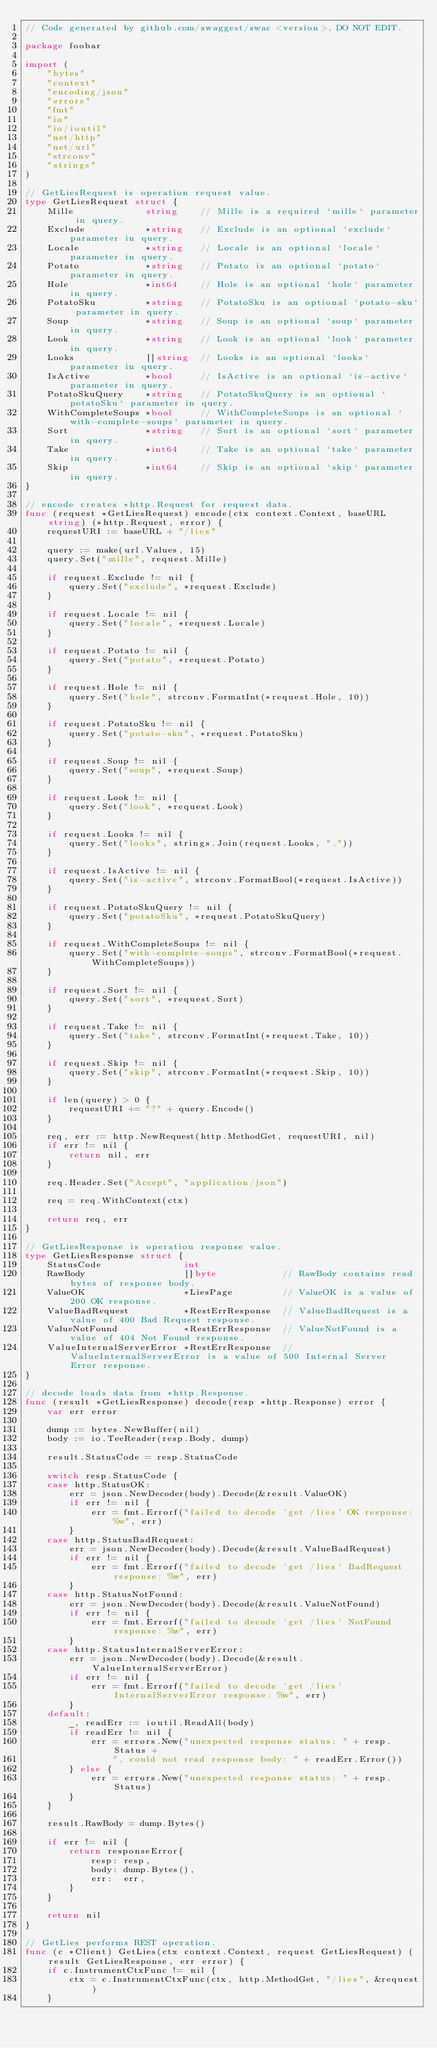<code> <loc_0><loc_0><loc_500><loc_500><_Go_>// Code generated by github.com/swaggest/swac <version>, DO NOT EDIT.

package foobar

import (
	"bytes"
	"context"
	"encoding/json"
	"errors"
	"fmt"
	"io"
	"io/ioutil"
	"net/http"
	"net/url"
	"strconv"
	"strings"
)

// GetLiesRequest is operation request value.
type GetLiesRequest struct {
	Mille             string    // Mille is a required `mille` parameter in query.
	Exclude           *string   // Exclude is an optional `exclude` parameter in query.
	Locale            *string   // Locale is an optional `locale` parameter in query.
	Potato            *string   // Potato is an optional `potato` parameter in query.
	Hole              *int64    // Hole is an optional `hole` parameter in query.
	PotatoSku         *string   // PotatoSku is an optional `potato-sku` parameter in query.
	Soup              *string   // Soup is an optional `soup` parameter in query.
	Look              *string   // Look is an optional `look` parameter in query.
	Looks             []string  // Looks is an optional `looks` parameter in query.
	IsActive          *bool     // IsActive is an optional `is-active` parameter in query.
	PotatoSkuQuery    *string   // PotatoSkuQuery is an optional `potatoSku` parameter in query.
	WithCompleteSoups *bool     // WithCompleteSoups is an optional `with-complete-soups` parameter in query.
	Sort              *string   // Sort is an optional `sort` parameter in query.
	Take              *int64    // Take is an optional `take` parameter in query.
	Skip              *int64    // Skip is an optional `skip` parameter in query.
}

// encode creates *http.Request for request data.
func (request *GetLiesRequest) encode(ctx context.Context, baseURL string) (*http.Request, error) {
	requestURI := baseURL + "/lies"

	query := make(url.Values, 15)
	query.Set("mille", request.Mille)

	if request.Exclude != nil {
		query.Set("exclude", *request.Exclude)
	}

	if request.Locale != nil {
		query.Set("locale", *request.Locale)
	}

	if request.Potato != nil {
		query.Set("potato", *request.Potato)
	}

	if request.Hole != nil {
		query.Set("hole", strconv.FormatInt(*request.Hole, 10))
	}

	if request.PotatoSku != nil {
		query.Set("potato-sku", *request.PotatoSku)
	}

	if request.Soup != nil {
		query.Set("soup", *request.Soup)
	}

	if request.Look != nil {
		query.Set("look", *request.Look)
	}

	if request.Looks != nil {
		query.Set("looks", strings.Join(request.Looks, ","))
	}

	if request.IsActive != nil {
		query.Set("is-active", strconv.FormatBool(*request.IsActive))
	}

	if request.PotatoSkuQuery != nil {
		query.Set("potatoSku", *request.PotatoSkuQuery)
	}

	if request.WithCompleteSoups != nil {
		query.Set("with-complete-soups", strconv.FormatBool(*request.WithCompleteSoups))
	}

	if request.Sort != nil {
		query.Set("sort", *request.Sort)
	}

	if request.Take != nil {
		query.Set("take", strconv.FormatInt(*request.Take, 10))
	}

	if request.Skip != nil {
		query.Set("skip", strconv.FormatInt(*request.Skip, 10))
	}

	if len(query) > 0 {
		requestURI += "?" + query.Encode()
	}

	req, err := http.NewRequest(http.MethodGet, requestURI, nil)
	if err != nil {
		return nil, err
	}

	req.Header.Set("Accept", "application/json")

	req = req.WithContext(ctx)

	return req, err
}

// GetLiesResponse is operation response value.
type GetLiesResponse struct {
	StatusCode               int
	RawBody                  []byte            // RawBody contains read bytes of response body.
	ValueOK                  *LiesPage         // ValueOK is a value of 200 OK response.
	ValueBadRequest          *RestErrResponse  // ValueBadRequest is a value of 400 Bad Request response.
	ValueNotFound            *RestErrResponse  // ValueNotFound is a value of 404 Not Found response.
	ValueInternalServerError *RestErrResponse  // ValueInternalServerError is a value of 500 Internal Server Error response.
}

// decode loads data from *http.Response.
func (result *GetLiesResponse) decode(resp *http.Response) error {
	var err error

	dump := bytes.NewBuffer(nil)
	body := io.TeeReader(resp.Body, dump)

	result.StatusCode = resp.StatusCode

	switch resp.StatusCode {
	case http.StatusOK:
		err = json.NewDecoder(body).Decode(&result.ValueOK)
		if err != nil {
			err = fmt.Errorf("failed to decode 'get /lies' OK response: %w", err)
		}
	case http.StatusBadRequest:
		err = json.NewDecoder(body).Decode(&result.ValueBadRequest)
		if err != nil {
			err = fmt.Errorf("failed to decode 'get /lies' BadRequest response: %w", err)
		}
	case http.StatusNotFound:
		err = json.NewDecoder(body).Decode(&result.ValueNotFound)
		if err != nil {
			err = fmt.Errorf("failed to decode 'get /lies' NotFound response: %w", err)
		}
	case http.StatusInternalServerError:
		err = json.NewDecoder(body).Decode(&result.ValueInternalServerError)
		if err != nil {
			err = fmt.Errorf("failed to decode 'get /lies' InternalServerError response: %w", err)
		}
	default:
		_, readErr := ioutil.ReadAll(body)
		if readErr != nil {
			err = errors.New("unexpected response status: " + resp.Status +
				", could not read response body: " + readErr.Error())
		} else {
			err = errors.New("unexpected response status: " + resp.Status)
		}
	}

	result.RawBody = dump.Bytes()

	if err != nil {
		return responseError{
			resp: resp,
			body: dump.Bytes(),
			err:  err,
		}
	}

	return nil
}

// GetLies performs REST operation.
func (c *Client) GetLies(ctx context.Context, request GetLiesRequest) (result GetLiesResponse, err error) {
	if c.InstrumentCtxFunc != nil {
		ctx = c.InstrumentCtxFunc(ctx, http.MethodGet, "/lies", &request)
	}
</code> 